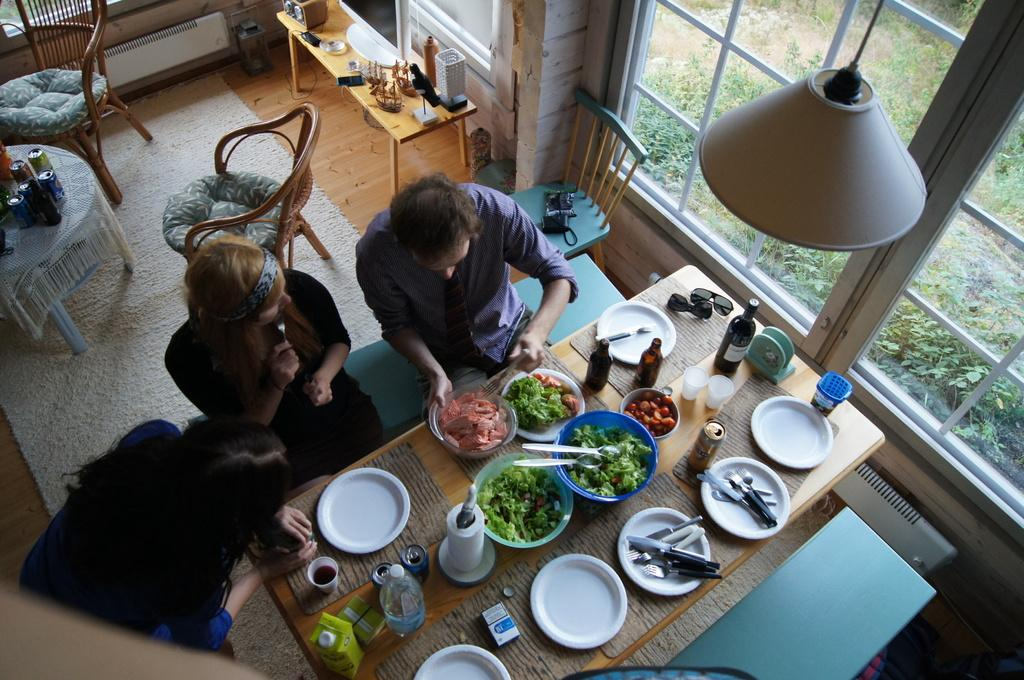How many people are in the image? There are two women and a man in the image. What is in front of the people? There is a table in front of them. What can be seen on the table? There are many things on the table. What is visible in the background of the image? There is a window in the image. What furniture is present in the image? There are chairs in the image. What architectural element can be seen in the image? There is a wall visible in the image. What time of day is it in the image, based on the presence of a beggar? There is no beggar present in the image, so we cannot determine the time of day based on that information. 